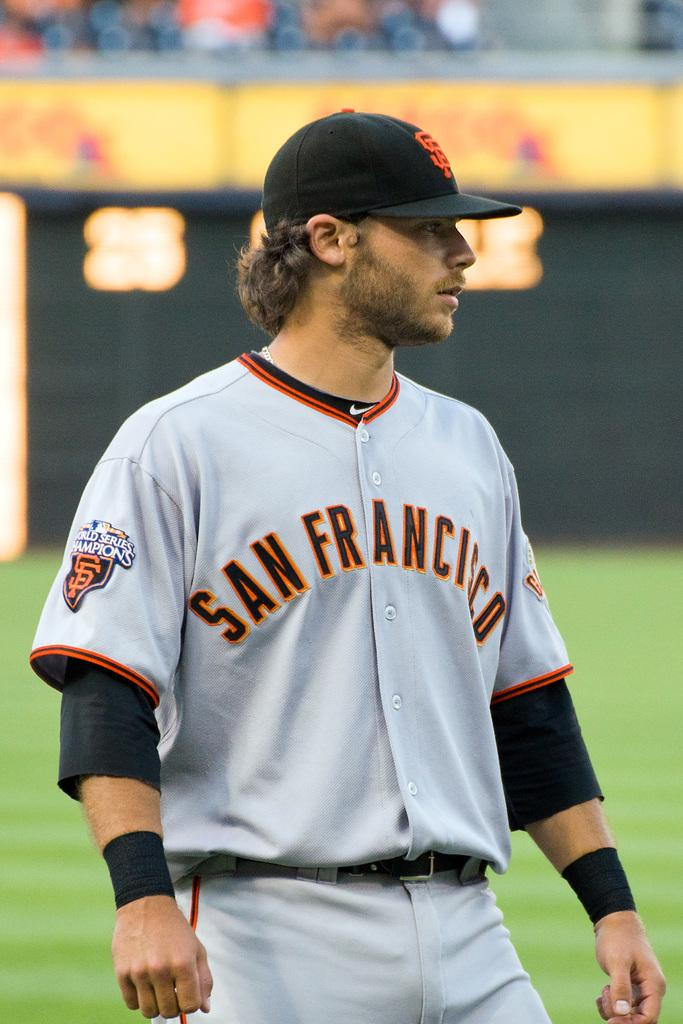<image>
Render a clear and concise summary of the photo. a baseball player with a World Series Champions patch on his sleeve and SAN FRANCISCO on the front of his uniform. 